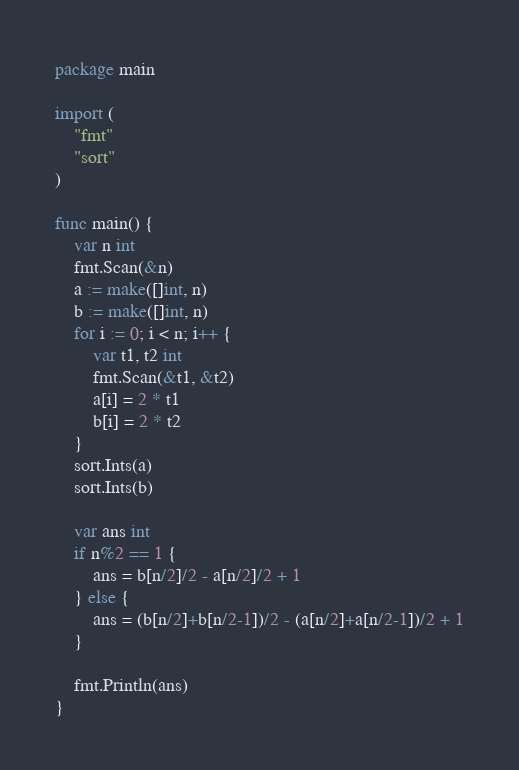<code> <loc_0><loc_0><loc_500><loc_500><_Go_>package main

import (
	"fmt"
	"sort"
)

func main() {
	var n int
	fmt.Scan(&n)
	a := make([]int, n)
	b := make([]int, n)
	for i := 0; i < n; i++ {
		var t1, t2 int
		fmt.Scan(&t1, &t2)
		a[i] = 2 * t1
		b[i] = 2 * t2
	}
	sort.Ints(a)
	sort.Ints(b)

	var ans int
	if n%2 == 1 {
		ans = b[n/2]/2 - a[n/2]/2 + 1
	} else {
		ans = (b[n/2]+b[n/2-1])/2 - (a[n/2]+a[n/2-1])/2 + 1
	}

	fmt.Println(ans)
}
</code> 